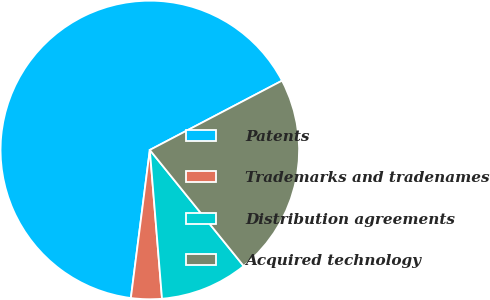Convert chart. <chart><loc_0><loc_0><loc_500><loc_500><pie_chart><fcel>Patents<fcel>Trademarks and tradenames<fcel>Distribution agreements<fcel>Acquired technology<nl><fcel>65.29%<fcel>3.33%<fcel>9.52%<fcel>21.86%<nl></chart> 